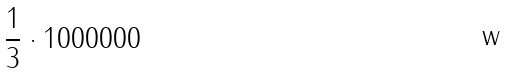<formula> <loc_0><loc_0><loc_500><loc_500>\frac { 1 } { 3 } \cdot 1 0 0 0 0 0 0</formula> 